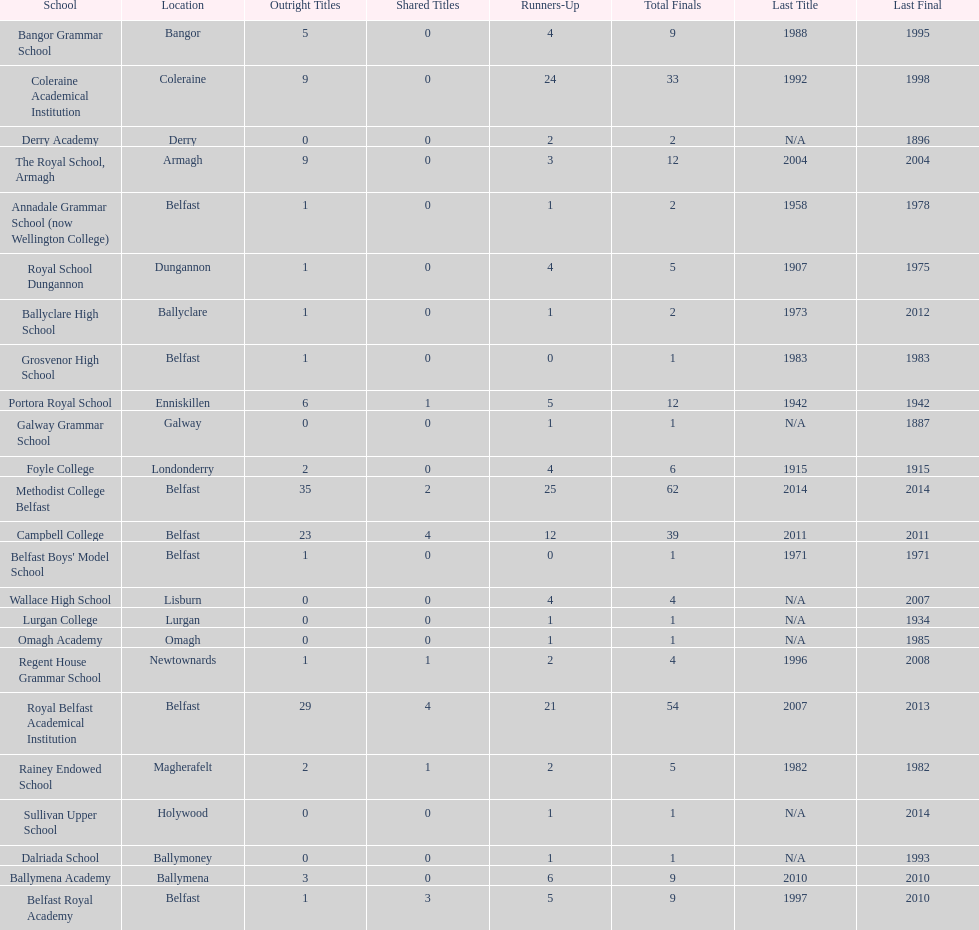Which schools have the largest number of shared titles? Royal Belfast Academical Institution, Campbell College. 